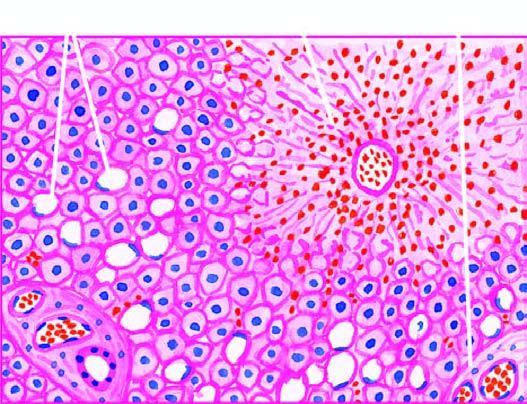what does the peripheral zone show?
Answer the question using a single word or phrase. Mild fatty change of liver cells 